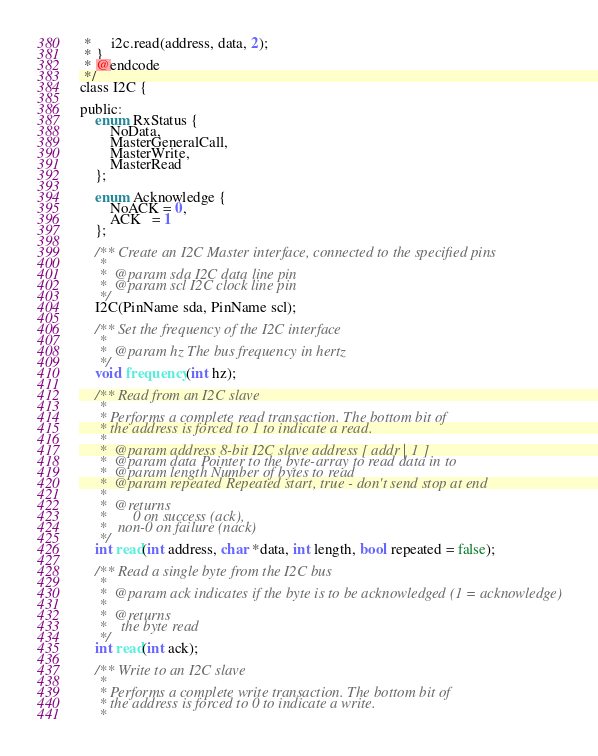<code> <loc_0><loc_0><loc_500><loc_500><_C_> *     i2c.read(address, data, 2);
 * }
 * @endcode
 */
class I2C {

public:
    enum RxStatus {
        NoData,
        MasterGeneralCall,
        MasterWrite,
        MasterRead
    };

    enum Acknowledge {
        NoACK = 0,
        ACK   = 1
    };

    /** Create an I2C Master interface, connected to the specified pins
     *
     *  @param sda I2C data line pin
     *  @param scl I2C clock line pin
     */
    I2C(PinName sda, PinName scl);

    /** Set the frequency of the I2C interface
     *
     *  @param hz The bus frequency in hertz
     */
    void frequency(int hz);

    /** Read from an I2C slave
     *
     * Performs a complete read transaction. The bottom bit of
     * the address is forced to 1 to indicate a read.
     *
     *  @param address 8-bit I2C slave address [ addr | 1 ]
     *  @param data Pointer to the byte-array to read data in to
     *  @param length Number of bytes to read
     *  @param repeated Repeated start, true - don't send stop at end
     *
     *  @returns
     *       0 on success (ack),
     *   non-0 on failure (nack)
     */
    int read(int address, char *data, int length, bool repeated = false);

    /** Read a single byte from the I2C bus
     *
     *  @param ack indicates if the byte is to be acknowledged (1 = acknowledge)
     *
     *  @returns
     *    the byte read
     */
    int read(int ack);

    /** Write to an I2C slave
     *
     * Performs a complete write transaction. The bottom bit of
     * the address is forced to 0 to indicate a write.
     *</code> 